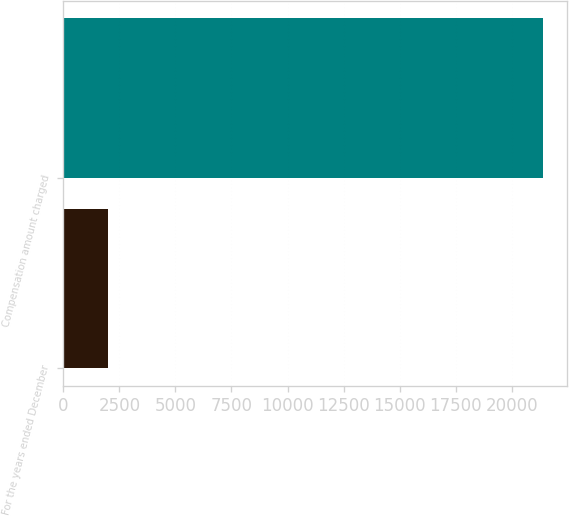Convert chart. <chart><loc_0><loc_0><loc_500><loc_500><bar_chart><fcel>For the years ended December<fcel>Compensation amount charged<nl><fcel>2013<fcel>21390<nl></chart> 